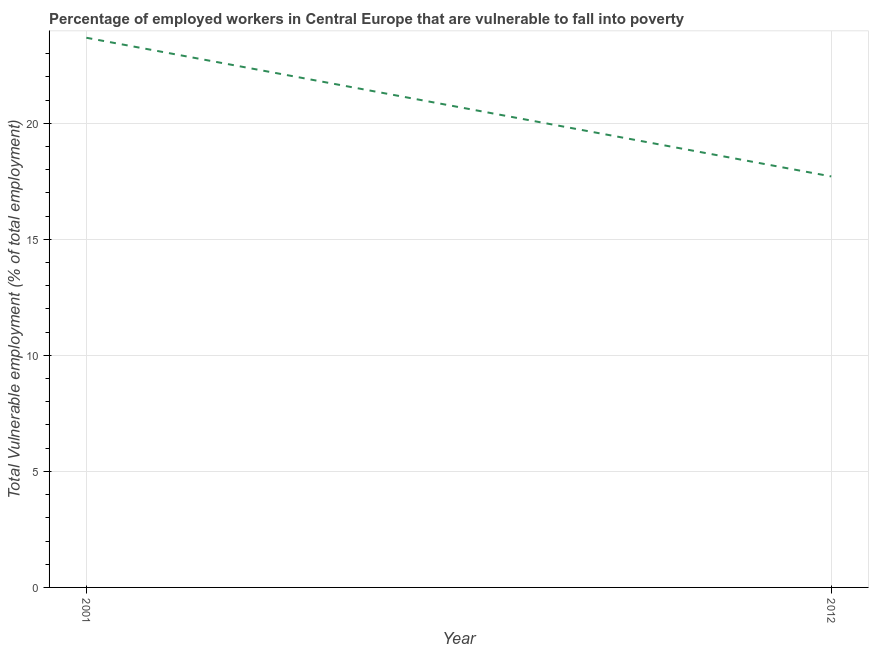What is the total vulnerable employment in 2001?
Give a very brief answer. 23.68. Across all years, what is the maximum total vulnerable employment?
Provide a succinct answer. 23.68. Across all years, what is the minimum total vulnerable employment?
Ensure brevity in your answer.  17.71. In which year was the total vulnerable employment minimum?
Your response must be concise. 2012. What is the sum of the total vulnerable employment?
Your answer should be very brief. 41.39. What is the difference between the total vulnerable employment in 2001 and 2012?
Your answer should be compact. 5.98. What is the average total vulnerable employment per year?
Provide a short and direct response. 20.7. What is the median total vulnerable employment?
Your answer should be compact. 20.7. In how many years, is the total vulnerable employment greater than 17 %?
Provide a short and direct response. 2. Do a majority of the years between 2001 and 2012 (inclusive) have total vulnerable employment greater than 7 %?
Your answer should be compact. Yes. What is the ratio of the total vulnerable employment in 2001 to that in 2012?
Make the answer very short. 1.34. Is the total vulnerable employment in 2001 less than that in 2012?
Your response must be concise. No. In how many years, is the total vulnerable employment greater than the average total vulnerable employment taken over all years?
Make the answer very short. 1. How many lines are there?
Provide a succinct answer. 1. How many years are there in the graph?
Offer a very short reply. 2. Does the graph contain any zero values?
Your response must be concise. No. Does the graph contain grids?
Offer a terse response. Yes. What is the title of the graph?
Give a very brief answer. Percentage of employed workers in Central Europe that are vulnerable to fall into poverty. What is the label or title of the X-axis?
Your answer should be very brief. Year. What is the label or title of the Y-axis?
Your answer should be very brief. Total Vulnerable employment (% of total employment). What is the Total Vulnerable employment (% of total employment) of 2001?
Offer a very short reply. 23.68. What is the Total Vulnerable employment (% of total employment) of 2012?
Keep it short and to the point. 17.71. What is the difference between the Total Vulnerable employment (% of total employment) in 2001 and 2012?
Your answer should be compact. 5.98. What is the ratio of the Total Vulnerable employment (% of total employment) in 2001 to that in 2012?
Keep it short and to the point. 1.34. 